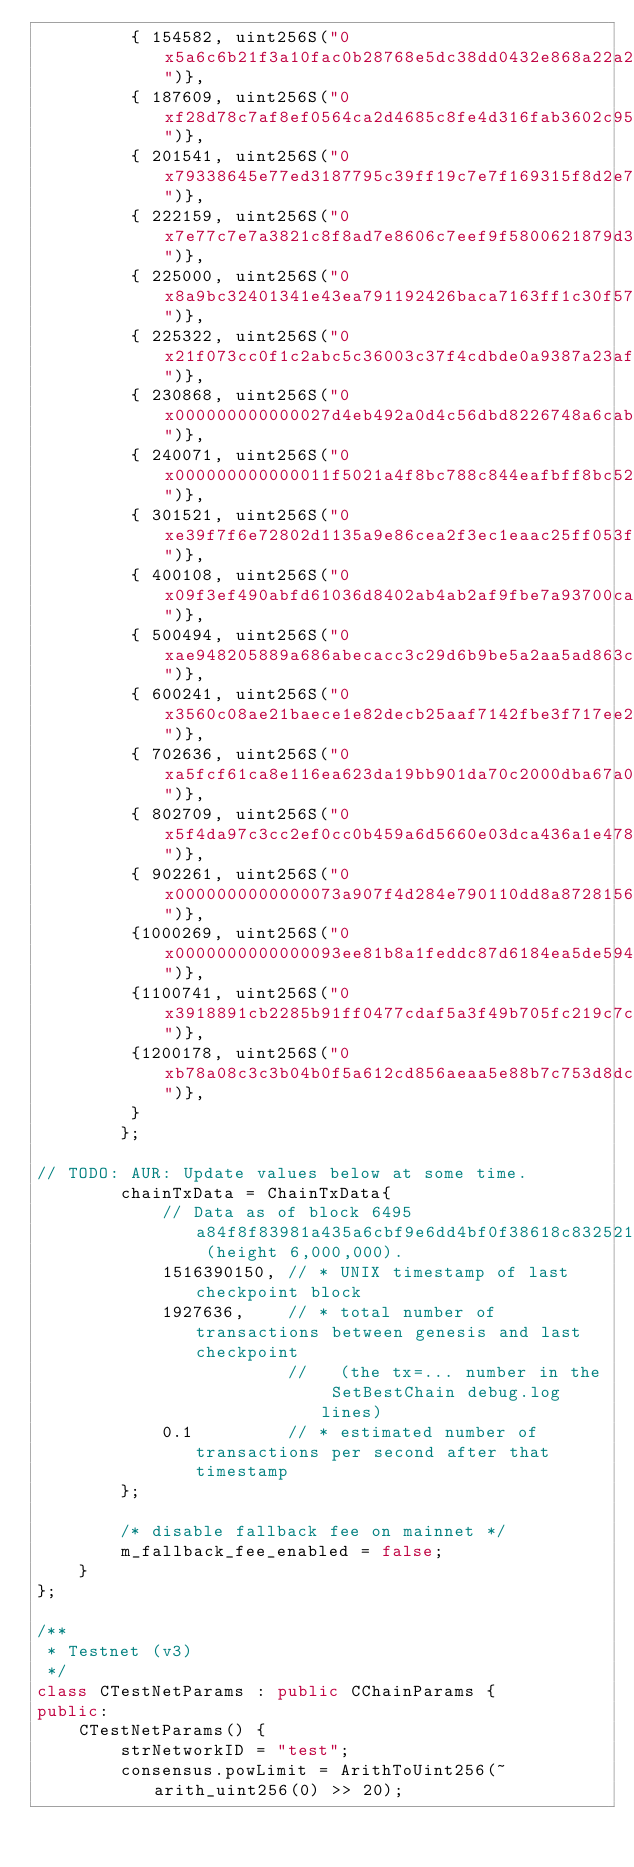Convert code to text. <code><loc_0><loc_0><loc_500><loc_500><_C++_>         { 154582, uint256S("0x5a6c6b21f3a10fac0b28768e5dc38dd0432e868a22a23650f37d170790a4e7e7")},
         { 187609, uint256S("0xf28d78c7af8ef0564ca2d4685c8fe4d316fab3602c95f97773ab04cc488aa457")},
         { 201541, uint256S("0x79338645e77ed3187795c39ff19c7e7f169315f8d2e70406f7e1843a1797d29e")},
         { 222159, uint256S("0x7e77c7e7a3821c8f8ad7e8606c7eef9f5800621879d336a42f58354d37901338")},
         { 225000, uint256S("0x8a9bc32401341e43ea791192426baca7163ff1c30f57fdd6c682bddab3fef7cb")},
         { 225322, uint256S("0x21f073cc0f1c2abc5c36003c37f4cdbde0a9387a23af9d123331a7cf7907ced5")},
         { 230868, uint256S("0x000000000000027d4eb492a0d4c56dbd8226748a6cab75a8dfa5709f2bcc128c")},
         { 240071, uint256S("0x000000000000011f5021a4f8bc788c844eafbff8bc52401b3b38b42c83e12a7b")},
         { 301521, uint256S("0xe39f7f6e72802d1135a9e86cea2f3ec1eaac25ff053f299558fdafaaa52586a1")},
         { 400108, uint256S("0x09f3ef490abfd61036d8402ab4ab2af9fbe7a93700cac73712889efb4e820d28")},
         { 500494, uint256S("0xae948205889a686abecacc3c29d6b9be5a2aa5ad863c2c5acbdaf3f6436b0117")},
         { 600241, uint256S("0x3560c08ae21baece1e82decb25aaf7142fbe3f717ee240e506bf0e12e20854cf")},
         { 702636, uint256S("0xa5fcf61ca8e116ea623da19bb901da70c2000dba67a0016271223467d0090eb3")},
         { 802709, uint256S("0x5f4da97c3cc2ef0cc0b459a6d5660e03dca436a1e478ca2103714b28e68d2679")},
         { 902261, uint256S("0x0000000000000073a907f4d284e790110dd8a87281566507a78f1060e106434e")},
         {1000269, uint256S("0x0000000000000093ee81b8a1feddc87d6184ea5de5947723df3fc75ab4dbd9db")},
         {1100741, uint256S("0x3918891cb2285b91ff0477cdaf5a3f49b705fc219c7ce8f036993d48af43d0df")},
         {1200178, uint256S("0xb78a08c3c3b04b0f5a612cd856aeaa5e88b7c753d8dc059bbe407f8eead75deb")},
         }
        };

// TODO: AUR: Update values below at some time.
        chainTxData = ChainTxData{
            // Data as of block 6495a84f8f83981a435a6cbf9e6dd4bf0f38618c8325213ca6ef6add40c0ddd8 (height 6,000,000).
            1516390150, // * UNIX timestamp of last checkpoint block
            1927636,    // * total number of transactions between genesis and last checkpoint
                        //   (the tx=... number in the SetBestChain debug.log lines)
            0.1         // * estimated number of transactions per second after that timestamp
        };

        /* disable fallback fee on mainnet */
        m_fallback_fee_enabled = false;
    }
};

/**
 * Testnet (v3)
 */
class CTestNetParams : public CChainParams {
public:
    CTestNetParams() {
        strNetworkID = "test";
        consensus.powLimit = ArithToUint256(~arith_uint256(0) >> 20);</code> 